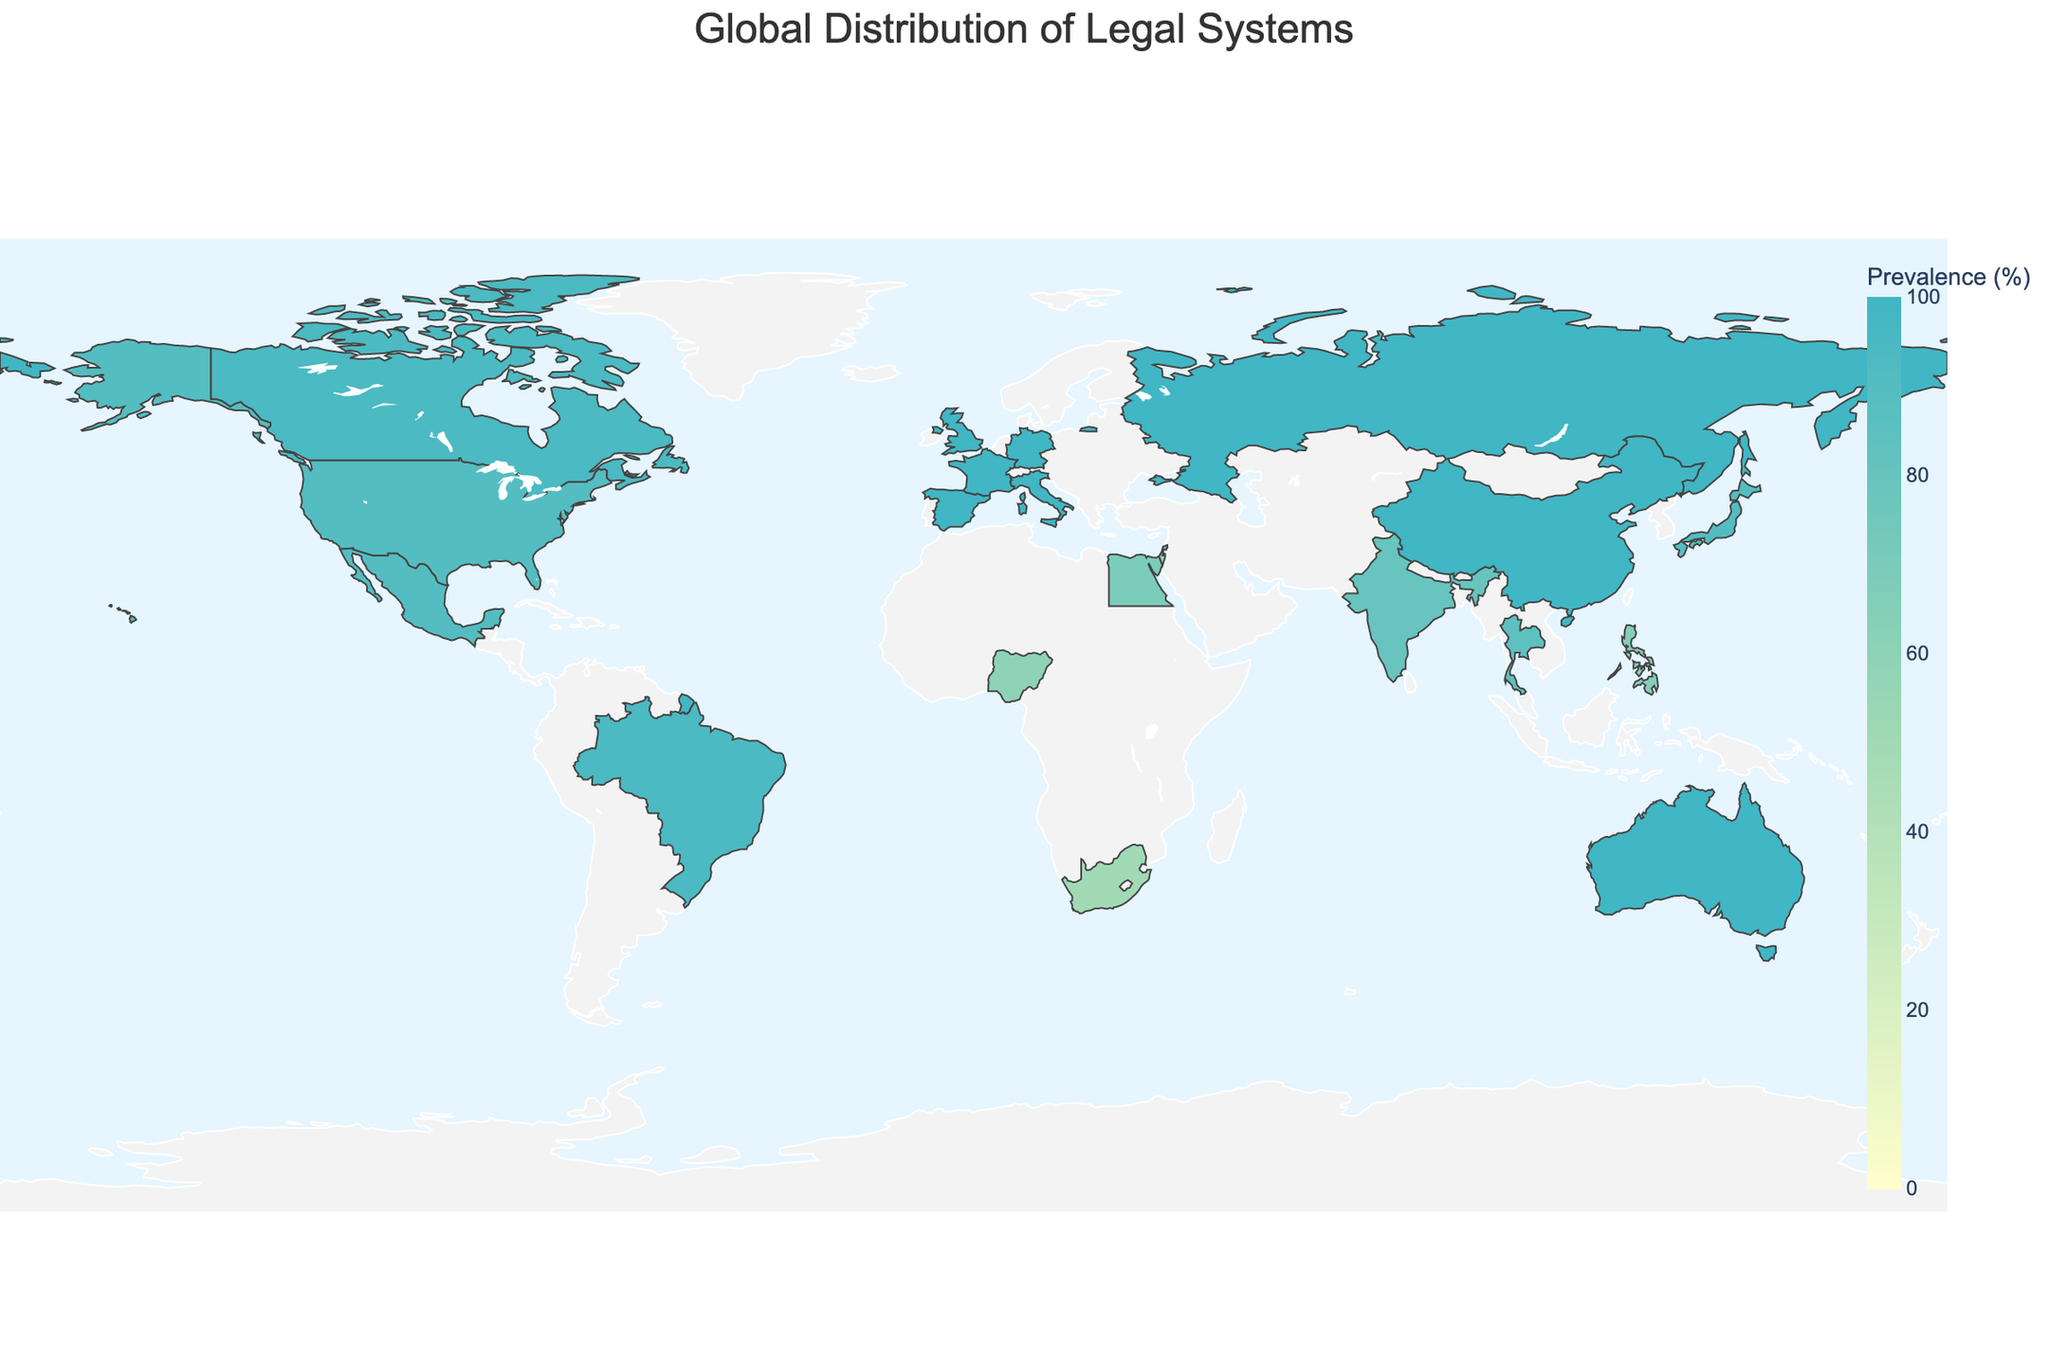What is the title of the figure? The title of the figure is provided at the top and summarizes the information depicted. It helps viewers understand what the map is about at a glance.
Answer: Global Distribution of Legal Systems Which countries have a 100% prevalence of civil law systems? Look at the color coding and hover data to identify countries with 100% prevalence of civil law systems. These regions will be consistently colored according to the scale.
Answer: Germany, France, China, Russia, Italy, Spain Is there any country with a prevalence of mixed legal systems above 60%? Locate the countries marked as having mixed legal systems with data points and check if their prevalence percentages exceed 60%. Based on hover information, we can identify such countries easily.
Answer: Egypt Compare the percentage of common law system prevalence in the United States and India. Which country has a higher percentage and by how much? Check the hover data for both the United States and India. The United States has a 90% prevalence, and India has 80%. Subtract India's percentage from the United States'.
Answer: The United States by 10% How many countries have more than 90% prevalence of their respective legal systems? Identify all countries with prevalence percentages above 90% by referring to the hover data in the figure. Count these countries across all legal systems.
Answer: 10 countries Which country has the lowest prevalence of its dominant legal system? Examine the percentage prevalence data for all countries and identify the country with the lowest number.
Answer: South Africa (Mixed, 50%) Compare the prevalence of civil law systems in Japan and Thailand. Which country has a lower percentage and by how much? Look at the specific prevalence percentages for Japan and Thailand from the hover data. Japan has 90%, Thailand has 85%. Subtract Thailand's percentage from Japan's.
Answer: Thailand by 5% What is the average prevalence percentage of civil law systems among the countries listed? To find the average, sum the prevalence percentages of all countries with civil law systems and divide by their total number.
Answer: (100 + 100 + 90 + 100 + 95 + 100 + 85 + 90 + 100 + 100)/10 = 96 Which region has the highest number of countries with mixed legal systems? Observe the countries designated with mixed legal systems and identify their geographic region. Since both regions in Africa and Asia appear multiple times, count occurrences to compare.
Answer: Africa Does any country have exactly 95% prevalence of its legal system? If so, which one(s)? Use the hover data to identify countries with exactly 95% prevalence. Look for color coding that corresponds to 95% and cross-verify.
Answer: Canada, Brazil 